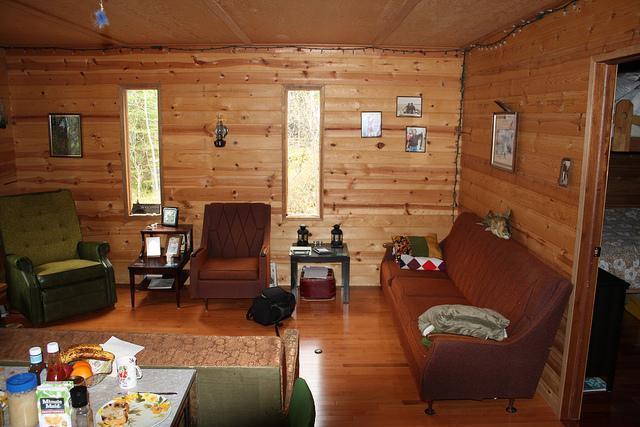How many windows are in the room?
Give a very brief answer. 2. How many couches are in the picture?
Give a very brief answer. 3. How many chairs are there?
Give a very brief answer. 2. 